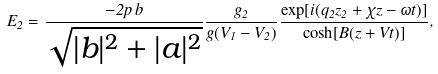<formula> <loc_0><loc_0><loc_500><loc_500>E _ { 2 } = \frac { - 2 p \, b } { \sqrt { | b | ^ { 2 } + | a | ^ { 2 } } } \frac { g _ { 2 } } { g ( V _ { 1 } - V _ { 2 } ) } \frac { \exp [ i ( q _ { 2 } z _ { 2 } + \chi z - \omega t ) ] } { \cosh [ B ( z + V t ) ] } ,</formula> 